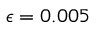Convert formula to latex. <formula><loc_0><loc_0><loc_500><loc_500>\epsilon = 0 . 0 0 5</formula> 